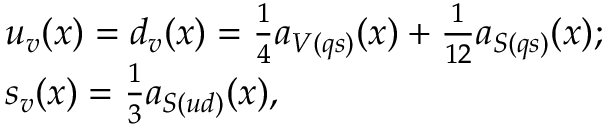Convert formula to latex. <formula><loc_0><loc_0><loc_500><loc_500>\begin{array} { c l c r & { { u _ { v } ( x ) = d _ { v } ( x ) = \frac { 1 } { 4 } a _ { V ( q s ) } ( x ) + \frac { 1 } { 1 2 } a _ { S ( q s ) } ( x ) ; } } & { { s _ { v } ( x ) = \frac { 1 } { 3 } a _ { S ( u d ) } ( x ) , } } \end{array}</formula> 